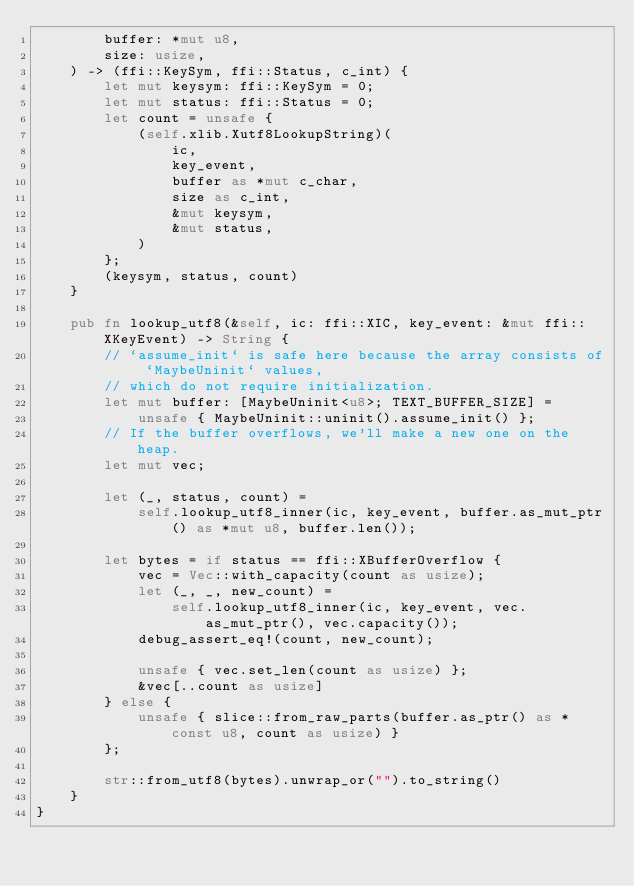<code> <loc_0><loc_0><loc_500><loc_500><_Rust_>        buffer: *mut u8,
        size: usize,
    ) -> (ffi::KeySym, ffi::Status, c_int) {
        let mut keysym: ffi::KeySym = 0;
        let mut status: ffi::Status = 0;
        let count = unsafe {
            (self.xlib.Xutf8LookupString)(
                ic,
                key_event,
                buffer as *mut c_char,
                size as c_int,
                &mut keysym,
                &mut status,
            )
        };
        (keysym, status, count)
    }

    pub fn lookup_utf8(&self, ic: ffi::XIC, key_event: &mut ffi::XKeyEvent) -> String {
        // `assume_init` is safe here because the array consists of `MaybeUninit` values,
        // which do not require initialization.
        let mut buffer: [MaybeUninit<u8>; TEXT_BUFFER_SIZE] =
            unsafe { MaybeUninit::uninit().assume_init() };
        // If the buffer overflows, we'll make a new one on the heap.
        let mut vec;

        let (_, status, count) =
            self.lookup_utf8_inner(ic, key_event, buffer.as_mut_ptr() as *mut u8, buffer.len());

        let bytes = if status == ffi::XBufferOverflow {
            vec = Vec::with_capacity(count as usize);
            let (_, _, new_count) =
                self.lookup_utf8_inner(ic, key_event, vec.as_mut_ptr(), vec.capacity());
            debug_assert_eq!(count, new_count);

            unsafe { vec.set_len(count as usize) };
            &vec[..count as usize]
        } else {
            unsafe { slice::from_raw_parts(buffer.as_ptr() as *const u8, count as usize) }
        };

        str::from_utf8(bytes).unwrap_or("").to_string()
    }
}
</code> 